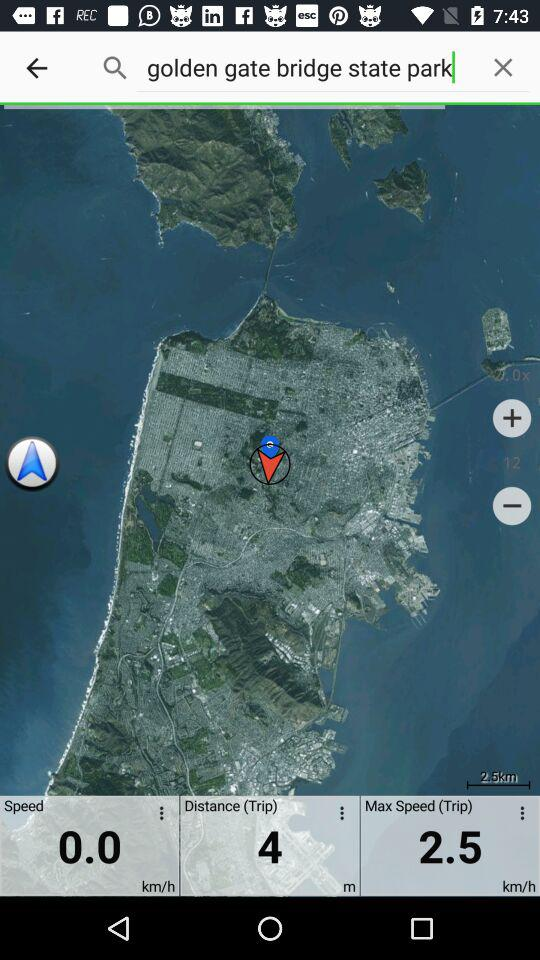How long is the trip?
Answer the question using a single word or phrase. 4 m 